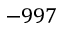<formula> <loc_0><loc_0><loc_500><loc_500>- 9 9 7</formula> 